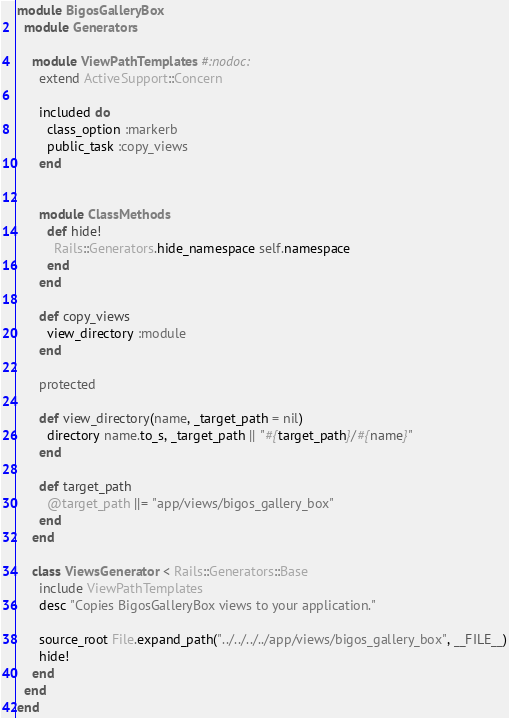Convert code to text. <code><loc_0><loc_0><loc_500><loc_500><_Ruby_>module BigosGalleryBox
  module Generators

    module ViewPathTemplates #:nodoc:
      extend ActiveSupport::Concern

      included do
        class_option :markerb
        public_task :copy_views
      end


      module ClassMethods
        def hide!
          Rails::Generators.hide_namespace self.namespace
        end
      end

      def copy_views
        view_directory :module
      end

      protected

      def view_directory(name, _target_path = nil)
        directory name.to_s, _target_path || "#{target_path}/#{name}"
      end

      def target_path
        @target_path ||= "app/views/bigos_gallery_box"
      end
    end

    class ViewsGenerator < Rails::Generators::Base
      include ViewPathTemplates
      desc "Copies BigosGalleryBox views to your application."

      source_root File.expand_path("../../../../app/views/bigos_gallery_box", __FILE__)
      hide!
    end
  end
end
</code> 